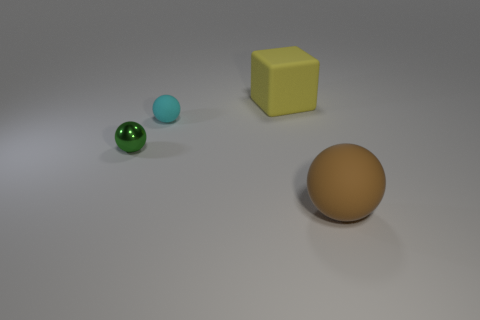How many objects are either tiny cyan rubber spheres or small cyan metal balls?
Your answer should be very brief. 1. Is the size of the matte object that is behind the cyan ball the same as the matte ball that is behind the green metallic sphere?
Keep it short and to the point. No. What number of cylinders are either tiny rubber things or tiny things?
Provide a short and direct response. 0. Are any metal spheres visible?
Provide a short and direct response. Yes. Are there any other things that have the same shape as the large brown object?
Provide a short and direct response. Yes. Is the large sphere the same color as the shiny sphere?
Offer a terse response. No. What number of objects are either matte things behind the green object or tiny brown objects?
Your answer should be very brief. 2. What number of large matte blocks are on the left side of the large matte object that is in front of the large object behind the tiny cyan rubber ball?
Ensure brevity in your answer.  1. Are there any other things that have the same size as the yellow rubber block?
Your answer should be compact. Yes. There is a matte object that is in front of the ball behind the ball that is to the left of the small cyan thing; what is its shape?
Make the answer very short. Sphere. 